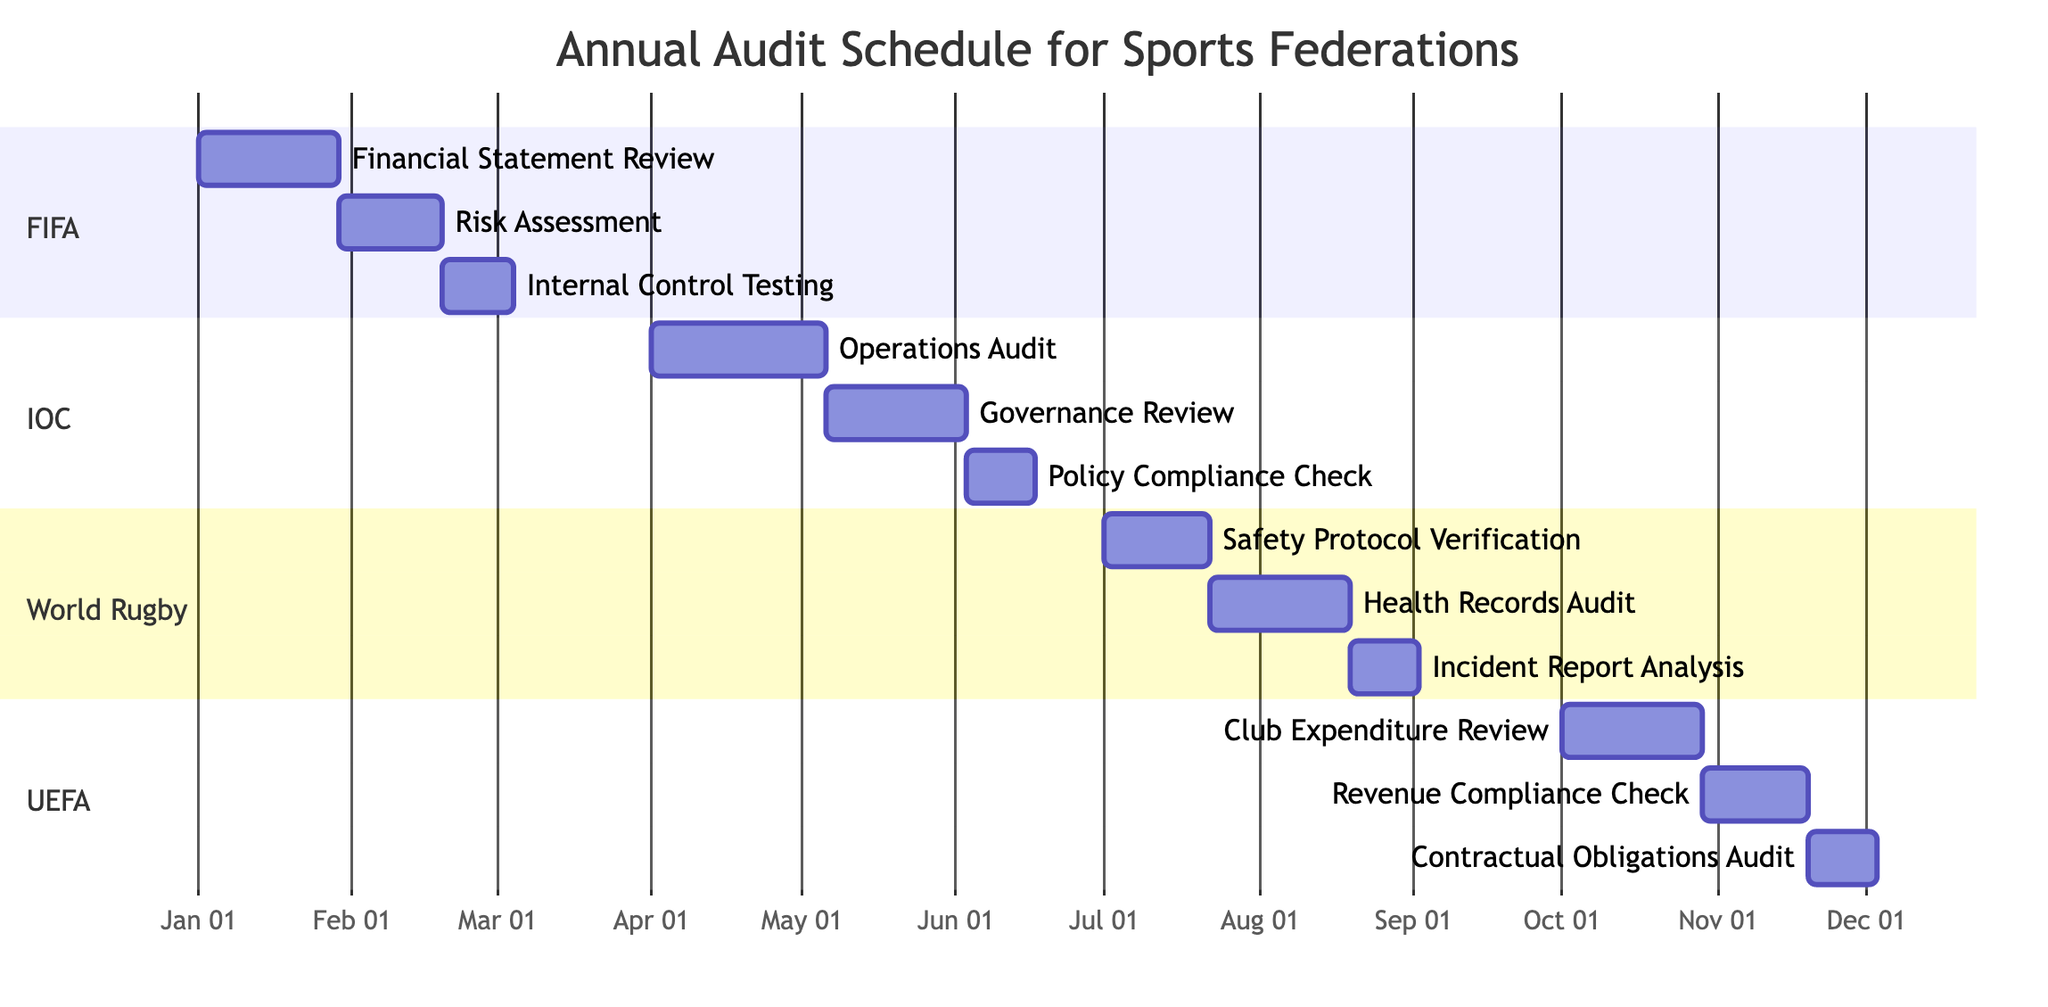What is the scope of FIFA's audit? The diagram shows that the scope of FIFA's audit is "Financial Compliance and Fraud Detection." This information is listed directly under the section dedicated to FIFA.
Answer: Financial Compliance and Fraud Detection When is the deadline for the International Olympic Committee's audit? According to the diagram, the deadline for the IOC’s audit is listed as "June 30." This is found in the section for the IOC.
Answer: June 30 How many tasks are outlined for UEFA's audit? The UEFA section includes three specific tasks for the audit as indicated in the diagram: "Club Expenditure Review," "Revenue Compliance Check," and "Contractual Obligations Audit." Thus, there are three tasks.
Answer: 3 What is the duration of the Operations Audit for the IOC? The diagram indicates that the duration of the "Operations Audit" task for the IOC is "5 weeks." This is specified directly in the relevant section.
Answer: 5 weeks Which federation has an audit focused on Health and Safety Compliance? The diagram specifies that "World Rugby" is the federation conducting an audit with a focus on "Health and Safety Compliance," as demonstrated in its section.
Answer: World Rugby What is the start date for the Health Records Audit in World Rugby? From the diagram, the "Health Records Audit" task for World Rugby starts on "July 22." This date is explicitly stated under the World Rugby section.
Answer: July 22 Which task has the shortest duration in FIFA's audit? In the FIFA section, the tasks listed are "Financial Statement Review" (4 weeks), "Risk Assessment" (3 weeks), and "Internal Control Testing" (2 weeks). The task with the shortest duration is "Internal Control Testing."
Answer: Internal Control Testing What is the deadline for UEFA's audit? The diagram clearly lists the deadline for UEFA's audit as "December 31." This information is found in the section dedicated to UEFA.
Answer: December 31 What type of compliance is being audited in Q3 for World Rugby? The diagram shows that the audits being conducted for World Rugby in Q3 focus on "Health and Safety Compliance." This is present in the title of the World Rugby section.
Answer: Health and Safety Compliance 